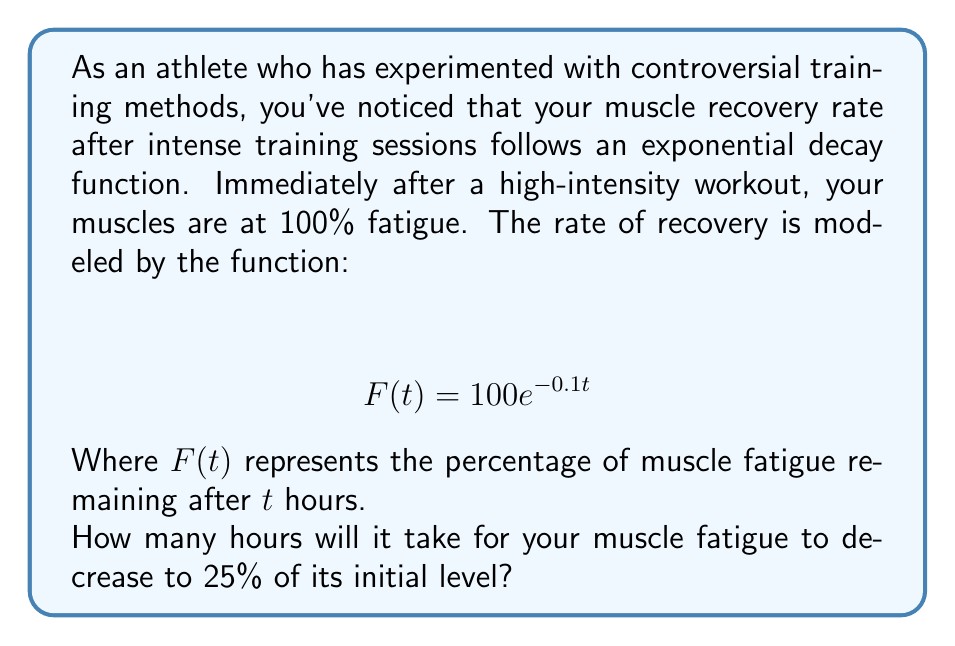What is the answer to this math problem? To solve this problem, we need to use the given exponential decay function and solve for $t$ when $F(t) = 25$.

1) We start with the equation:
   $$ F(t) = 100e^{-0.1t} $$

2) We want to find $t$ when $F(t) = 25$, so we substitute this:
   $$ 25 = 100e^{-0.1t} $$

3) Divide both sides by 100:
   $$ 0.25 = e^{-0.1t} $$

4) Take the natural logarithm of both sides:
   $$ \ln(0.25) = \ln(e^{-0.1t}) $$

5) Simplify the right side using the property of logarithms:
   $$ \ln(0.25) = -0.1t $$

6) Calculate $\ln(0.25)$:
   $$ -1.3863 = -0.1t $$

7) Divide both sides by -0.1:
   $$ \frac{-1.3863}{-0.1} = t $$

8) Calculate the final result:
   $$ 13.863 = t $$

Therefore, it will take approximately 13.86 hours for your muscle fatigue to decrease to 25% of its initial level.
Answer: 13.86 hours 